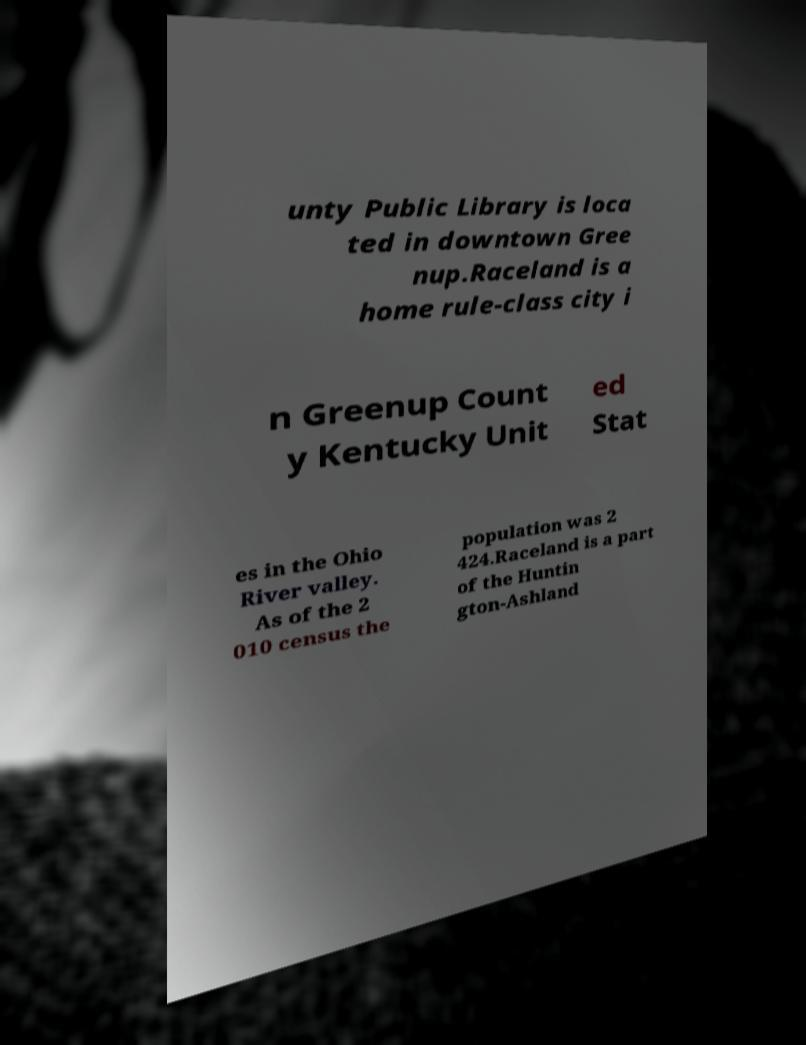Please read and relay the text visible in this image. What does it say? unty Public Library is loca ted in downtown Gree nup.Raceland is a home rule-class city i n Greenup Count y Kentucky Unit ed Stat es in the Ohio River valley. As of the 2 010 census the population was 2 424.Raceland is a part of the Huntin gton-Ashland 